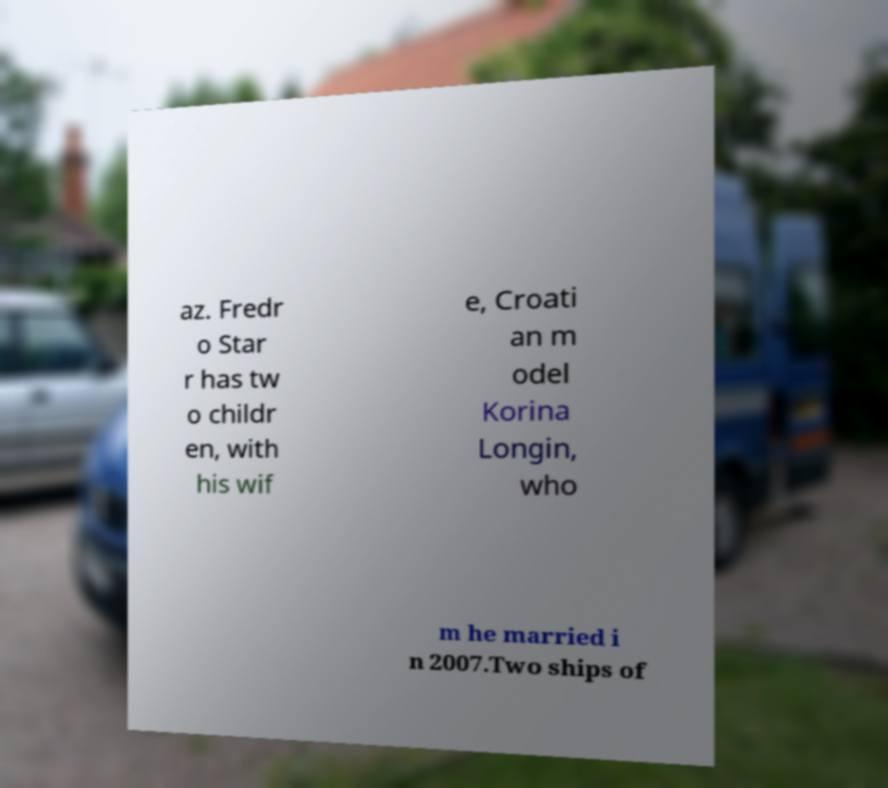I need the written content from this picture converted into text. Can you do that? az. Fredr o Star r has tw o childr en, with his wif e, Croati an m odel Korina Longin, who m he married i n 2007.Two ships of 